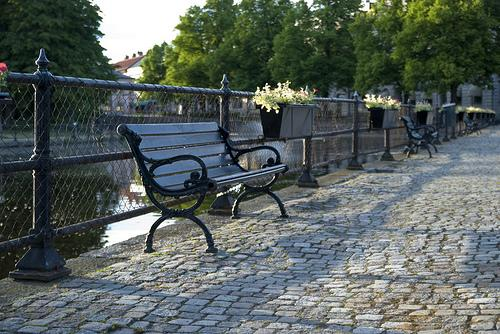What is the sidewalk made of?

Choices:
A) cobblestones
B) concrete
C) slate
D) brick cobblestones 